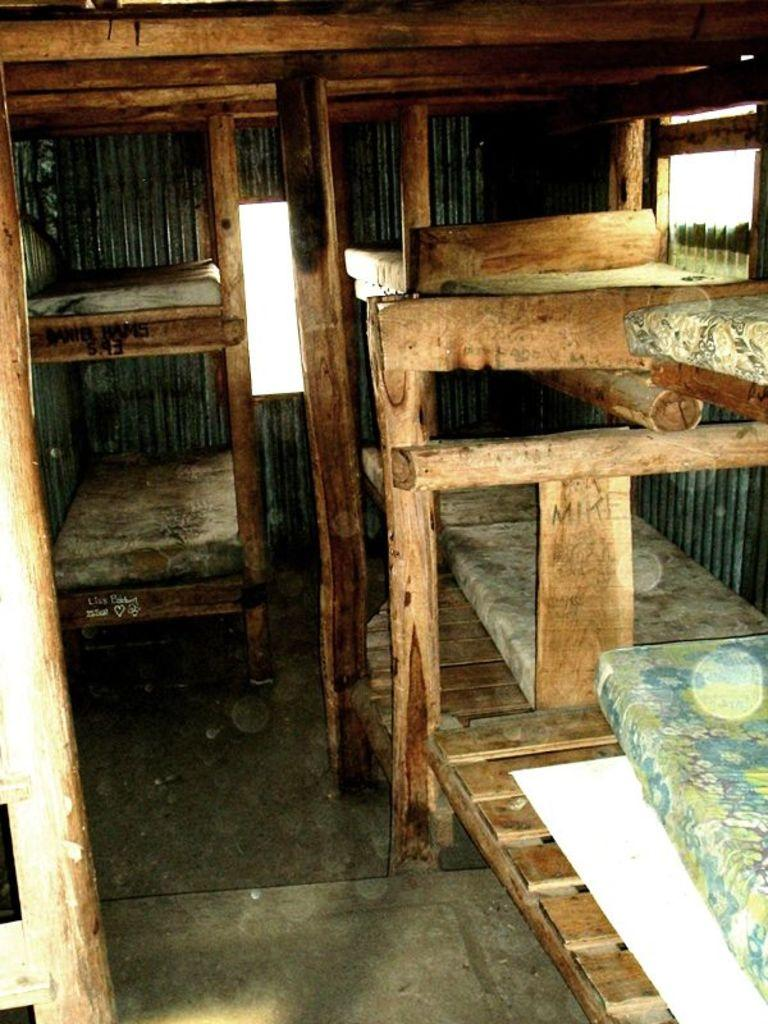What type of furniture is present in the image? There is a cot in the image. What material is used for the poles in the image? The poles in the image are made of wood. Where is the window located in the image? The window is in the top right corner of the image. What type of structure might the image have been taken in? The image might have been taken in a wooden shed. What type of nerve can be seen in the image? There is no nerve present in the image. How many wheels are visible in the image? There are no wheels visible in the image. 